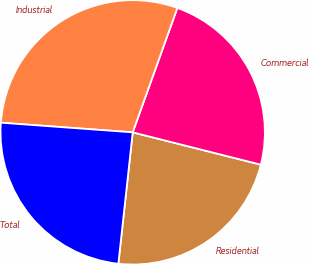Convert chart. <chart><loc_0><loc_0><loc_500><loc_500><pie_chart><fcel>Residential<fcel>Commercial<fcel>Industrial<fcel>Total<nl><fcel>22.8%<fcel>23.45%<fcel>29.32%<fcel>24.43%<nl></chart> 